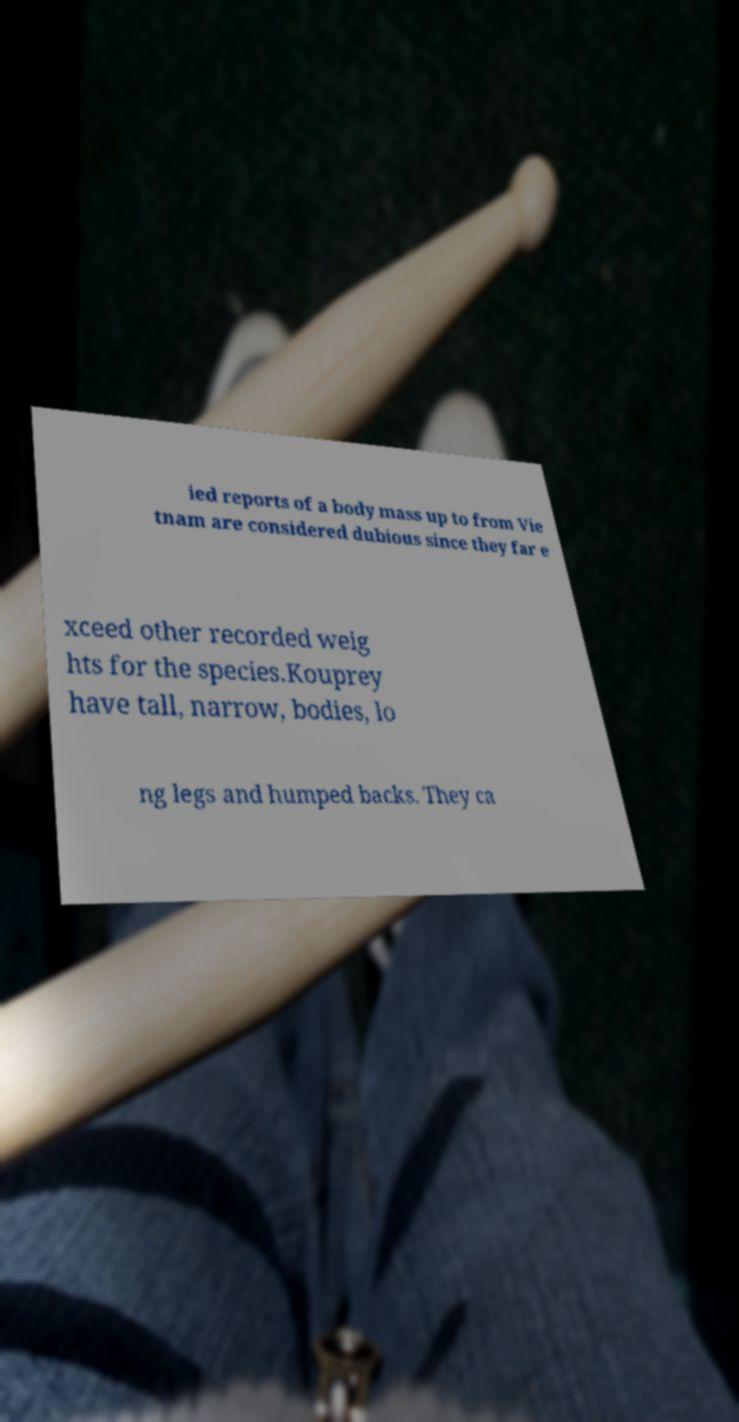Could you assist in decoding the text presented in this image and type it out clearly? ied reports of a body mass up to from Vie tnam are considered dubious since they far e xceed other recorded weig hts for the species.Kouprey have tall, narrow, bodies, lo ng legs and humped backs. They ca 